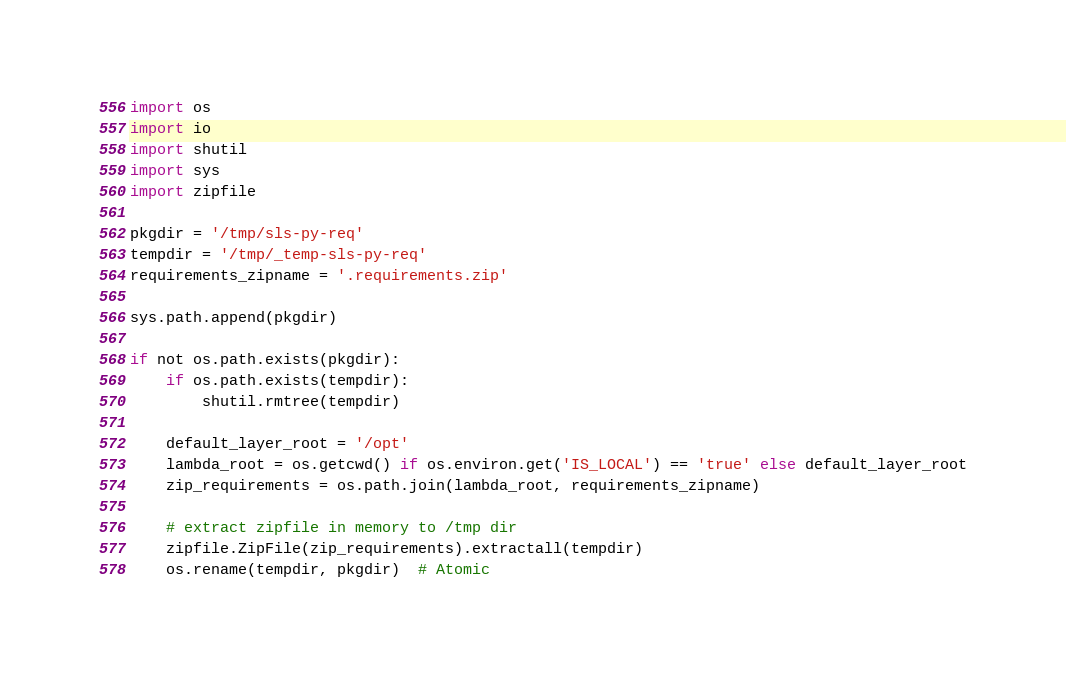<code> <loc_0><loc_0><loc_500><loc_500><_Python_>import os
import io
import shutil
import sys
import zipfile

pkgdir = '/tmp/sls-py-req'
tempdir = '/tmp/_temp-sls-py-req'
requirements_zipname = '.requirements.zip'

sys.path.append(pkgdir)

if not os.path.exists(pkgdir):
    if os.path.exists(tempdir):
        shutil.rmtree(tempdir)

    default_layer_root = '/opt'
    lambda_root = os.getcwd() if os.environ.get('IS_LOCAL') == 'true' else default_layer_root
    zip_requirements = os.path.join(lambda_root, requirements_zipname)

    # extract zipfile in memory to /tmp dir
    zipfile.ZipFile(zip_requirements).extractall(tempdir)
    os.rename(tempdir, pkgdir)  # Atomic</code> 